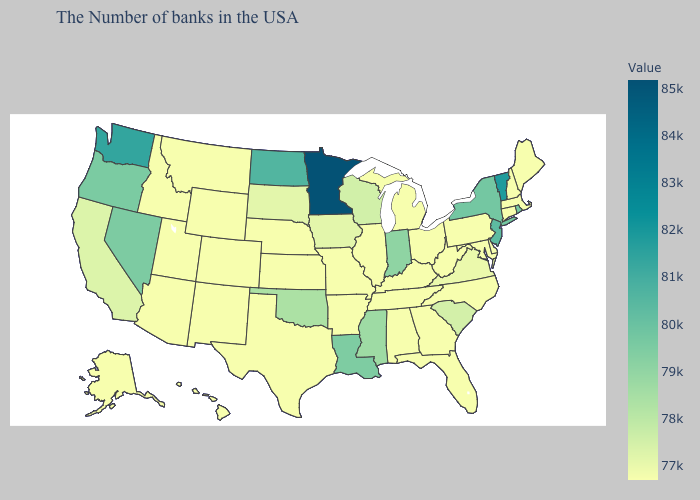Which states have the highest value in the USA?
Answer briefly. Minnesota. Does Utah have the lowest value in the West?
Short answer required. Yes. Does Kansas have the lowest value in the MidWest?
Concise answer only. Yes. Is the legend a continuous bar?
Write a very short answer. Yes. Does Michigan have a lower value than Louisiana?
Quick response, please. Yes. Does Rhode Island have the lowest value in the Northeast?
Short answer required. No. Does Wisconsin have the lowest value in the USA?
Keep it brief. No. 